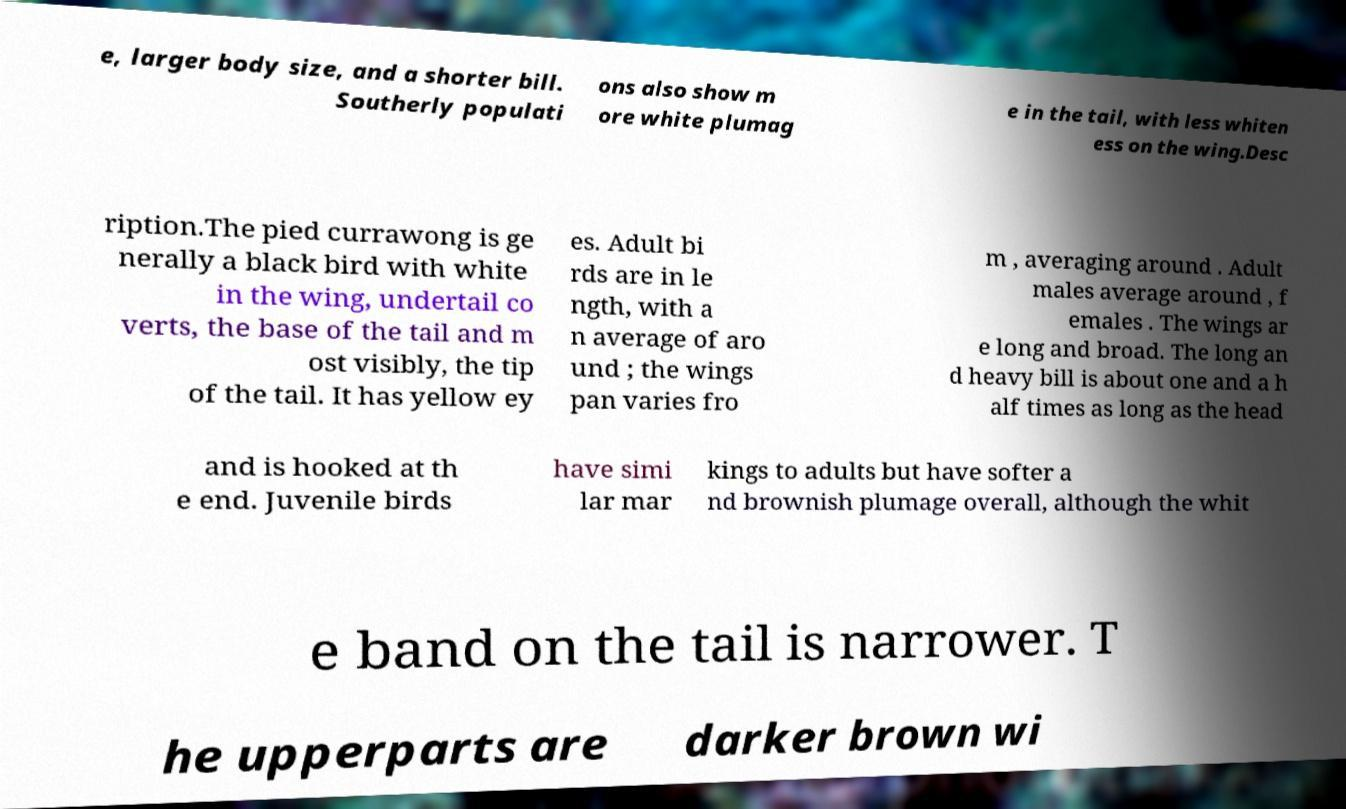For documentation purposes, I need the text within this image transcribed. Could you provide that? e, larger body size, and a shorter bill. Southerly populati ons also show m ore white plumag e in the tail, with less whiten ess on the wing.Desc ription.The pied currawong is ge nerally a black bird with white in the wing, undertail co verts, the base of the tail and m ost visibly, the tip of the tail. It has yellow ey es. Adult bi rds are in le ngth, with a n average of aro und ; the wings pan varies fro m , averaging around . Adult males average around , f emales . The wings ar e long and broad. The long an d heavy bill is about one and a h alf times as long as the head and is hooked at th e end. Juvenile birds have simi lar mar kings to adults but have softer a nd brownish plumage overall, although the whit e band on the tail is narrower. T he upperparts are darker brown wi 